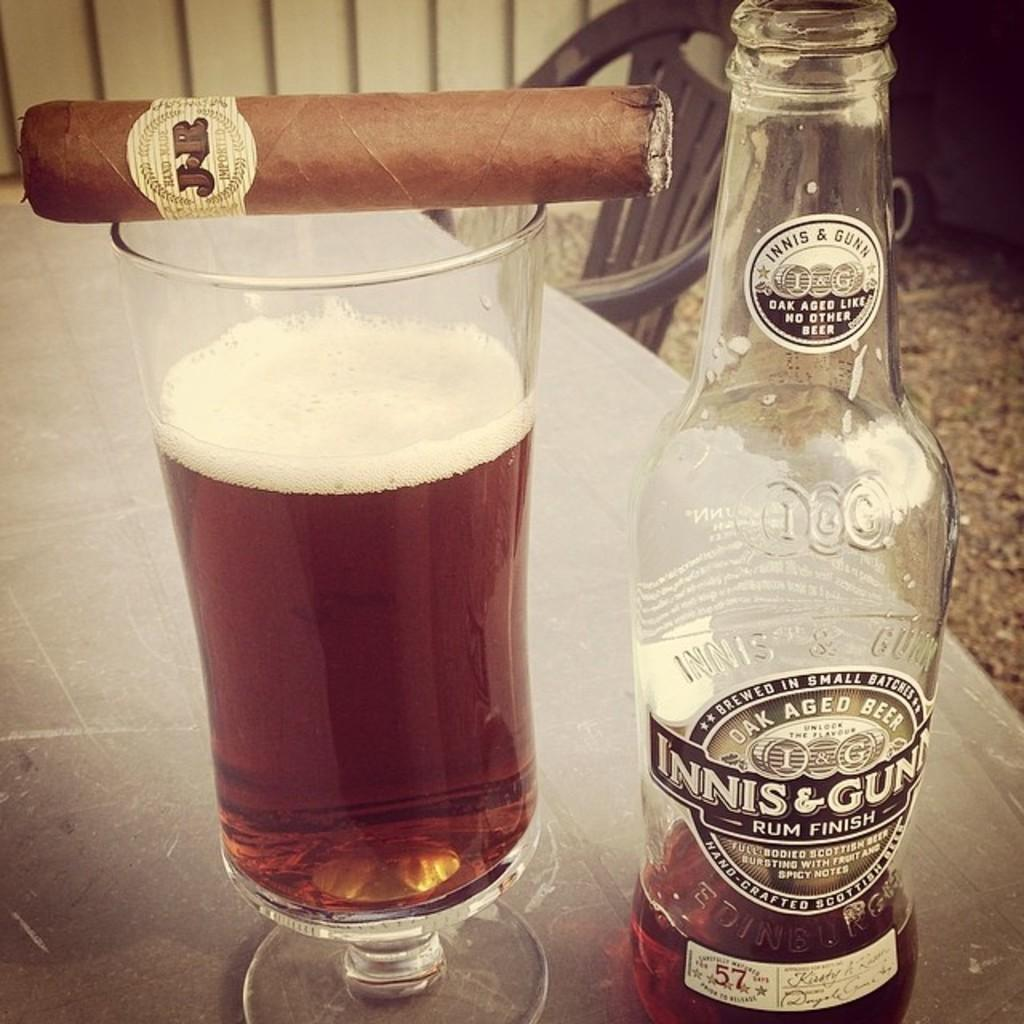Provide a one-sentence caption for the provided image. A mostly empty bottle of oak aged beer sits next to a glass with a cigar on top of it. 